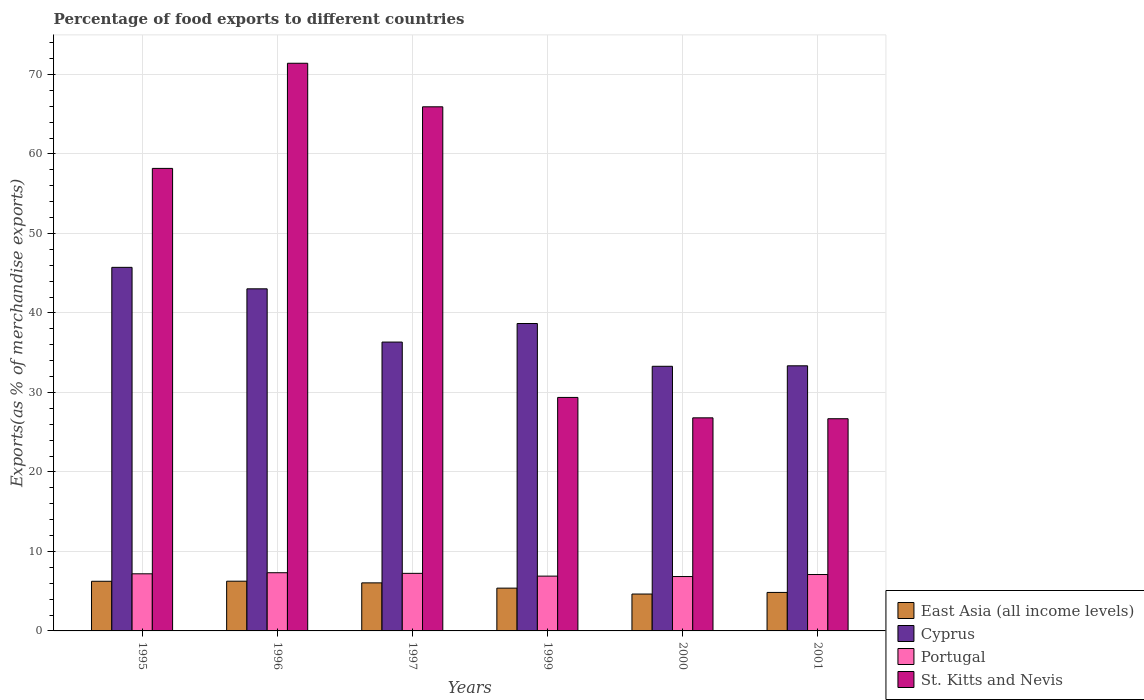How many different coloured bars are there?
Ensure brevity in your answer.  4. Are the number of bars per tick equal to the number of legend labels?
Ensure brevity in your answer.  Yes. How many bars are there on the 3rd tick from the left?
Make the answer very short. 4. What is the label of the 3rd group of bars from the left?
Provide a succinct answer. 1997. In how many cases, is the number of bars for a given year not equal to the number of legend labels?
Provide a short and direct response. 0. What is the percentage of exports to different countries in East Asia (all income levels) in 1997?
Offer a very short reply. 6.05. Across all years, what is the maximum percentage of exports to different countries in Cyprus?
Offer a terse response. 45.74. Across all years, what is the minimum percentage of exports to different countries in Cyprus?
Your answer should be compact. 33.29. In which year was the percentage of exports to different countries in St. Kitts and Nevis maximum?
Keep it short and to the point. 1996. What is the total percentage of exports to different countries in East Asia (all income levels) in the graph?
Provide a short and direct response. 33.41. What is the difference between the percentage of exports to different countries in Cyprus in 1996 and that in 1999?
Offer a terse response. 4.37. What is the difference between the percentage of exports to different countries in Cyprus in 2000 and the percentage of exports to different countries in Portugal in 1996?
Your response must be concise. 25.97. What is the average percentage of exports to different countries in East Asia (all income levels) per year?
Make the answer very short. 5.57. In the year 2001, what is the difference between the percentage of exports to different countries in Portugal and percentage of exports to different countries in St. Kitts and Nevis?
Make the answer very short. -19.6. What is the ratio of the percentage of exports to different countries in Cyprus in 1999 to that in 2001?
Offer a very short reply. 1.16. Is the percentage of exports to different countries in East Asia (all income levels) in 1996 less than that in 1997?
Provide a succinct answer. No. Is the difference between the percentage of exports to different countries in Portugal in 1996 and 2001 greater than the difference between the percentage of exports to different countries in St. Kitts and Nevis in 1996 and 2001?
Your response must be concise. No. What is the difference between the highest and the second highest percentage of exports to different countries in Portugal?
Provide a succinct answer. 0.08. What is the difference between the highest and the lowest percentage of exports to different countries in Portugal?
Your answer should be compact. 0.48. Is it the case that in every year, the sum of the percentage of exports to different countries in Cyprus and percentage of exports to different countries in St. Kitts and Nevis is greater than the sum of percentage of exports to different countries in East Asia (all income levels) and percentage of exports to different countries in Portugal?
Your answer should be very brief. No. What does the 1st bar from the left in 1997 represents?
Keep it short and to the point. East Asia (all income levels). What does the 4th bar from the right in 1999 represents?
Offer a terse response. East Asia (all income levels). Is it the case that in every year, the sum of the percentage of exports to different countries in Portugal and percentage of exports to different countries in Cyprus is greater than the percentage of exports to different countries in East Asia (all income levels)?
Provide a succinct answer. Yes. How many bars are there?
Offer a terse response. 24. How many years are there in the graph?
Your answer should be compact. 6. What is the difference between two consecutive major ticks on the Y-axis?
Offer a very short reply. 10. Does the graph contain any zero values?
Provide a succinct answer. No. Where does the legend appear in the graph?
Provide a short and direct response. Bottom right. What is the title of the graph?
Your response must be concise. Percentage of food exports to different countries. Does "Guyana" appear as one of the legend labels in the graph?
Provide a short and direct response. No. What is the label or title of the X-axis?
Provide a short and direct response. Years. What is the label or title of the Y-axis?
Your answer should be very brief. Exports(as % of merchandise exports). What is the Exports(as % of merchandise exports) of East Asia (all income levels) in 1995?
Your response must be concise. 6.24. What is the Exports(as % of merchandise exports) in Cyprus in 1995?
Provide a short and direct response. 45.74. What is the Exports(as % of merchandise exports) in Portugal in 1995?
Offer a terse response. 7.19. What is the Exports(as % of merchandise exports) in St. Kitts and Nevis in 1995?
Ensure brevity in your answer.  58.18. What is the Exports(as % of merchandise exports) in East Asia (all income levels) in 1996?
Give a very brief answer. 6.25. What is the Exports(as % of merchandise exports) of Cyprus in 1996?
Provide a short and direct response. 43.04. What is the Exports(as % of merchandise exports) in Portugal in 1996?
Offer a terse response. 7.32. What is the Exports(as % of merchandise exports) of St. Kitts and Nevis in 1996?
Provide a short and direct response. 71.41. What is the Exports(as % of merchandise exports) in East Asia (all income levels) in 1997?
Keep it short and to the point. 6.05. What is the Exports(as % of merchandise exports) of Cyprus in 1997?
Your answer should be very brief. 36.34. What is the Exports(as % of merchandise exports) in Portugal in 1997?
Your answer should be compact. 7.24. What is the Exports(as % of merchandise exports) in St. Kitts and Nevis in 1997?
Ensure brevity in your answer.  65.93. What is the Exports(as % of merchandise exports) in East Asia (all income levels) in 1999?
Offer a very short reply. 5.38. What is the Exports(as % of merchandise exports) in Cyprus in 1999?
Offer a terse response. 38.67. What is the Exports(as % of merchandise exports) in Portugal in 1999?
Keep it short and to the point. 6.89. What is the Exports(as % of merchandise exports) in St. Kitts and Nevis in 1999?
Your answer should be very brief. 29.37. What is the Exports(as % of merchandise exports) of East Asia (all income levels) in 2000?
Your answer should be compact. 4.64. What is the Exports(as % of merchandise exports) of Cyprus in 2000?
Offer a terse response. 33.29. What is the Exports(as % of merchandise exports) of Portugal in 2000?
Offer a terse response. 6.84. What is the Exports(as % of merchandise exports) of St. Kitts and Nevis in 2000?
Your response must be concise. 26.8. What is the Exports(as % of merchandise exports) in East Asia (all income levels) in 2001?
Your answer should be very brief. 4.84. What is the Exports(as % of merchandise exports) of Cyprus in 2001?
Your answer should be very brief. 33.35. What is the Exports(as % of merchandise exports) of Portugal in 2001?
Your answer should be very brief. 7.1. What is the Exports(as % of merchandise exports) in St. Kitts and Nevis in 2001?
Keep it short and to the point. 26.69. Across all years, what is the maximum Exports(as % of merchandise exports) of East Asia (all income levels)?
Your answer should be very brief. 6.25. Across all years, what is the maximum Exports(as % of merchandise exports) of Cyprus?
Your response must be concise. 45.74. Across all years, what is the maximum Exports(as % of merchandise exports) in Portugal?
Your answer should be compact. 7.32. Across all years, what is the maximum Exports(as % of merchandise exports) of St. Kitts and Nevis?
Provide a succinct answer. 71.41. Across all years, what is the minimum Exports(as % of merchandise exports) in East Asia (all income levels)?
Ensure brevity in your answer.  4.64. Across all years, what is the minimum Exports(as % of merchandise exports) of Cyprus?
Offer a terse response. 33.29. Across all years, what is the minimum Exports(as % of merchandise exports) of Portugal?
Provide a succinct answer. 6.84. Across all years, what is the minimum Exports(as % of merchandise exports) of St. Kitts and Nevis?
Your response must be concise. 26.69. What is the total Exports(as % of merchandise exports) in East Asia (all income levels) in the graph?
Give a very brief answer. 33.41. What is the total Exports(as % of merchandise exports) in Cyprus in the graph?
Keep it short and to the point. 230.42. What is the total Exports(as % of merchandise exports) of Portugal in the graph?
Offer a terse response. 42.58. What is the total Exports(as % of merchandise exports) in St. Kitts and Nevis in the graph?
Your response must be concise. 278.39. What is the difference between the Exports(as % of merchandise exports) of East Asia (all income levels) in 1995 and that in 1996?
Offer a terse response. -0.01. What is the difference between the Exports(as % of merchandise exports) in Cyprus in 1995 and that in 1996?
Your answer should be very brief. 2.7. What is the difference between the Exports(as % of merchandise exports) in Portugal in 1995 and that in 1996?
Offer a terse response. -0.14. What is the difference between the Exports(as % of merchandise exports) in St. Kitts and Nevis in 1995 and that in 1996?
Give a very brief answer. -13.23. What is the difference between the Exports(as % of merchandise exports) of East Asia (all income levels) in 1995 and that in 1997?
Your answer should be compact. 0.2. What is the difference between the Exports(as % of merchandise exports) in Cyprus in 1995 and that in 1997?
Provide a short and direct response. 9.4. What is the difference between the Exports(as % of merchandise exports) in Portugal in 1995 and that in 1997?
Offer a terse response. -0.06. What is the difference between the Exports(as % of merchandise exports) in St. Kitts and Nevis in 1995 and that in 1997?
Make the answer very short. -7.75. What is the difference between the Exports(as % of merchandise exports) of East Asia (all income levels) in 1995 and that in 1999?
Your answer should be compact. 0.86. What is the difference between the Exports(as % of merchandise exports) of Cyprus in 1995 and that in 1999?
Keep it short and to the point. 7.07. What is the difference between the Exports(as % of merchandise exports) of Portugal in 1995 and that in 1999?
Your answer should be compact. 0.29. What is the difference between the Exports(as % of merchandise exports) of St. Kitts and Nevis in 1995 and that in 1999?
Provide a short and direct response. 28.81. What is the difference between the Exports(as % of merchandise exports) of East Asia (all income levels) in 1995 and that in 2000?
Offer a very short reply. 1.6. What is the difference between the Exports(as % of merchandise exports) of Cyprus in 1995 and that in 2000?
Give a very brief answer. 12.45. What is the difference between the Exports(as % of merchandise exports) of Portugal in 1995 and that in 2000?
Offer a terse response. 0.35. What is the difference between the Exports(as % of merchandise exports) in St. Kitts and Nevis in 1995 and that in 2000?
Provide a short and direct response. 31.38. What is the difference between the Exports(as % of merchandise exports) in East Asia (all income levels) in 1995 and that in 2001?
Offer a very short reply. 1.4. What is the difference between the Exports(as % of merchandise exports) of Cyprus in 1995 and that in 2001?
Offer a very short reply. 12.38. What is the difference between the Exports(as % of merchandise exports) of Portugal in 1995 and that in 2001?
Your response must be concise. 0.09. What is the difference between the Exports(as % of merchandise exports) of St. Kitts and Nevis in 1995 and that in 2001?
Give a very brief answer. 31.49. What is the difference between the Exports(as % of merchandise exports) of East Asia (all income levels) in 1996 and that in 1997?
Offer a terse response. 0.21. What is the difference between the Exports(as % of merchandise exports) of Cyprus in 1996 and that in 1997?
Provide a succinct answer. 6.7. What is the difference between the Exports(as % of merchandise exports) in Portugal in 1996 and that in 1997?
Provide a short and direct response. 0.08. What is the difference between the Exports(as % of merchandise exports) of St. Kitts and Nevis in 1996 and that in 1997?
Your response must be concise. 5.48. What is the difference between the Exports(as % of merchandise exports) of East Asia (all income levels) in 1996 and that in 1999?
Your answer should be compact. 0.87. What is the difference between the Exports(as % of merchandise exports) in Cyprus in 1996 and that in 1999?
Your answer should be compact. 4.37. What is the difference between the Exports(as % of merchandise exports) in Portugal in 1996 and that in 1999?
Keep it short and to the point. 0.43. What is the difference between the Exports(as % of merchandise exports) in St. Kitts and Nevis in 1996 and that in 1999?
Provide a short and direct response. 42.04. What is the difference between the Exports(as % of merchandise exports) in East Asia (all income levels) in 1996 and that in 2000?
Offer a terse response. 1.61. What is the difference between the Exports(as % of merchandise exports) of Cyprus in 1996 and that in 2000?
Your answer should be compact. 9.74. What is the difference between the Exports(as % of merchandise exports) in Portugal in 1996 and that in 2000?
Your response must be concise. 0.48. What is the difference between the Exports(as % of merchandise exports) of St. Kitts and Nevis in 1996 and that in 2000?
Ensure brevity in your answer.  44.6. What is the difference between the Exports(as % of merchandise exports) of East Asia (all income levels) in 1996 and that in 2001?
Ensure brevity in your answer.  1.41. What is the difference between the Exports(as % of merchandise exports) of Cyprus in 1996 and that in 2001?
Provide a succinct answer. 9.68. What is the difference between the Exports(as % of merchandise exports) in Portugal in 1996 and that in 2001?
Ensure brevity in your answer.  0.23. What is the difference between the Exports(as % of merchandise exports) in St. Kitts and Nevis in 1996 and that in 2001?
Give a very brief answer. 44.72. What is the difference between the Exports(as % of merchandise exports) of East Asia (all income levels) in 1997 and that in 1999?
Your answer should be compact. 0.66. What is the difference between the Exports(as % of merchandise exports) of Cyprus in 1997 and that in 1999?
Your response must be concise. -2.33. What is the difference between the Exports(as % of merchandise exports) in Portugal in 1997 and that in 1999?
Make the answer very short. 0.35. What is the difference between the Exports(as % of merchandise exports) in St. Kitts and Nevis in 1997 and that in 1999?
Your answer should be compact. 36.56. What is the difference between the Exports(as % of merchandise exports) of East Asia (all income levels) in 1997 and that in 2000?
Provide a succinct answer. 1.41. What is the difference between the Exports(as % of merchandise exports) of Cyprus in 1997 and that in 2000?
Keep it short and to the point. 3.05. What is the difference between the Exports(as % of merchandise exports) of Portugal in 1997 and that in 2000?
Provide a succinct answer. 0.4. What is the difference between the Exports(as % of merchandise exports) of St. Kitts and Nevis in 1997 and that in 2000?
Ensure brevity in your answer.  39.13. What is the difference between the Exports(as % of merchandise exports) of East Asia (all income levels) in 1997 and that in 2001?
Provide a short and direct response. 1.2. What is the difference between the Exports(as % of merchandise exports) in Cyprus in 1997 and that in 2001?
Offer a very short reply. 2.98. What is the difference between the Exports(as % of merchandise exports) of Portugal in 1997 and that in 2001?
Offer a terse response. 0.15. What is the difference between the Exports(as % of merchandise exports) of St. Kitts and Nevis in 1997 and that in 2001?
Provide a succinct answer. 39.24. What is the difference between the Exports(as % of merchandise exports) in East Asia (all income levels) in 1999 and that in 2000?
Your answer should be compact. 0.74. What is the difference between the Exports(as % of merchandise exports) in Cyprus in 1999 and that in 2000?
Ensure brevity in your answer.  5.38. What is the difference between the Exports(as % of merchandise exports) of Portugal in 1999 and that in 2000?
Your answer should be very brief. 0.05. What is the difference between the Exports(as % of merchandise exports) in St. Kitts and Nevis in 1999 and that in 2000?
Your answer should be compact. 2.57. What is the difference between the Exports(as % of merchandise exports) in East Asia (all income levels) in 1999 and that in 2001?
Your answer should be compact. 0.54. What is the difference between the Exports(as % of merchandise exports) of Cyprus in 1999 and that in 2001?
Provide a short and direct response. 5.32. What is the difference between the Exports(as % of merchandise exports) of Portugal in 1999 and that in 2001?
Your response must be concise. -0.2. What is the difference between the Exports(as % of merchandise exports) of St. Kitts and Nevis in 1999 and that in 2001?
Make the answer very short. 2.68. What is the difference between the Exports(as % of merchandise exports) of East Asia (all income levels) in 2000 and that in 2001?
Offer a terse response. -0.2. What is the difference between the Exports(as % of merchandise exports) of Cyprus in 2000 and that in 2001?
Give a very brief answer. -0.06. What is the difference between the Exports(as % of merchandise exports) of Portugal in 2000 and that in 2001?
Your answer should be compact. -0.25. What is the difference between the Exports(as % of merchandise exports) of St. Kitts and Nevis in 2000 and that in 2001?
Offer a very short reply. 0.11. What is the difference between the Exports(as % of merchandise exports) of East Asia (all income levels) in 1995 and the Exports(as % of merchandise exports) of Cyprus in 1996?
Provide a succinct answer. -36.79. What is the difference between the Exports(as % of merchandise exports) of East Asia (all income levels) in 1995 and the Exports(as % of merchandise exports) of Portugal in 1996?
Your response must be concise. -1.08. What is the difference between the Exports(as % of merchandise exports) of East Asia (all income levels) in 1995 and the Exports(as % of merchandise exports) of St. Kitts and Nevis in 1996?
Your answer should be very brief. -65.16. What is the difference between the Exports(as % of merchandise exports) in Cyprus in 1995 and the Exports(as % of merchandise exports) in Portugal in 1996?
Offer a terse response. 38.41. What is the difference between the Exports(as % of merchandise exports) of Cyprus in 1995 and the Exports(as % of merchandise exports) of St. Kitts and Nevis in 1996?
Make the answer very short. -25.67. What is the difference between the Exports(as % of merchandise exports) in Portugal in 1995 and the Exports(as % of merchandise exports) in St. Kitts and Nevis in 1996?
Provide a succinct answer. -64.22. What is the difference between the Exports(as % of merchandise exports) of East Asia (all income levels) in 1995 and the Exports(as % of merchandise exports) of Cyprus in 1997?
Offer a very short reply. -30.09. What is the difference between the Exports(as % of merchandise exports) of East Asia (all income levels) in 1995 and the Exports(as % of merchandise exports) of Portugal in 1997?
Provide a succinct answer. -1. What is the difference between the Exports(as % of merchandise exports) of East Asia (all income levels) in 1995 and the Exports(as % of merchandise exports) of St. Kitts and Nevis in 1997?
Your response must be concise. -59.69. What is the difference between the Exports(as % of merchandise exports) in Cyprus in 1995 and the Exports(as % of merchandise exports) in Portugal in 1997?
Provide a short and direct response. 38.49. What is the difference between the Exports(as % of merchandise exports) in Cyprus in 1995 and the Exports(as % of merchandise exports) in St. Kitts and Nevis in 1997?
Ensure brevity in your answer.  -20.2. What is the difference between the Exports(as % of merchandise exports) in Portugal in 1995 and the Exports(as % of merchandise exports) in St. Kitts and Nevis in 1997?
Your response must be concise. -58.75. What is the difference between the Exports(as % of merchandise exports) in East Asia (all income levels) in 1995 and the Exports(as % of merchandise exports) in Cyprus in 1999?
Provide a succinct answer. -32.42. What is the difference between the Exports(as % of merchandise exports) of East Asia (all income levels) in 1995 and the Exports(as % of merchandise exports) of Portugal in 1999?
Your answer should be compact. -0.65. What is the difference between the Exports(as % of merchandise exports) in East Asia (all income levels) in 1995 and the Exports(as % of merchandise exports) in St. Kitts and Nevis in 1999?
Your answer should be very brief. -23.13. What is the difference between the Exports(as % of merchandise exports) in Cyprus in 1995 and the Exports(as % of merchandise exports) in Portugal in 1999?
Give a very brief answer. 38.84. What is the difference between the Exports(as % of merchandise exports) in Cyprus in 1995 and the Exports(as % of merchandise exports) in St. Kitts and Nevis in 1999?
Make the answer very short. 16.36. What is the difference between the Exports(as % of merchandise exports) of Portugal in 1995 and the Exports(as % of merchandise exports) of St. Kitts and Nevis in 1999?
Ensure brevity in your answer.  -22.19. What is the difference between the Exports(as % of merchandise exports) in East Asia (all income levels) in 1995 and the Exports(as % of merchandise exports) in Cyprus in 2000?
Provide a short and direct response. -27.05. What is the difference between the Exports(as % of merchandise exports) of East Asia (all income levels) in 1995 and the Exports(as % of merchandise exports) of Portugal in 2000?
Offer a very short reply. -0.6. What is the difference between the Exports(as % of merchandise exports) of East Asia (all income levels) in 1995 and the Exports(as % of merchandise exports) of St. Kitts and Nevis in 2000?
Provide a succinct answer. -20.56. What is the difference between the Exports(as % of merchandise exports) of Cyprus in 1995 and the Exports(as % of merchandise exports) of Portugal in 2000?
Your answer should be compact. 38.9. What is the difference between the Exports(as % of merchandise exports) of Cyprus in 1995 and the Exports(as % of merchandise exports) of St. Kitts and Nevis in 2000?
Ensure brevity in your answer.  18.93. What is the difference between the Exports(as % of merchandise exports) of Portugal in 1995 and the Exports(as % of merchandise exports) of St. Kitts and Nevis in 2000?
Ensure brevity in your answer.  -19.62. What is the difference between the Exports(as % of merchandise exports) in East Asia (all income levels) in 1995 and the Exports(as % of merchandise exports) in Cyprus in 2001?
Give a very brief answer. -27.11. What is the difference between the Exports(as % of merchandise exports) of East Asia (all income levels) in 1995 and the Exports(as % of merchandise exports) of Portugal in 2001?
Offer a terse response. -0.85. What is the difference between the Exports(as % of merchandise exports) of East Asia (all income levels) in 1995 and the Exports(as % of merchandise exports) of St. Kitts and Nevis in 2001?
Offer a terse response. -20.45. What is the difference between the Exports(as % of merchandise exports) in Cyprus in 1995 and the Exports(as % of merchandise exports) in Portugal in 2001?
Provide a succinct answer. 38.64. What is the difference between the Exports(as % of merchandise exports) of Cyprus in 1995 and the Exports(as % of merchandise exports) of St. Kitts and Nevis in 2001?
Your response must be concise. 19.04. What is the difference between the Exports(as % of merchandise exports) of Portugal in 1995 and the Exports(as % of merchandise exports) of St. Kitts and Nevis in 2001?
Offer a very short reply. -19.51. What is the difference between the Exports(as % of merchandise exports) in East Asia (all income levels) in 1996 and the Exports(as % of merchandise exports) in Cyprus in 1997?
Your response must be concise. -30.08. What is the difference between the Exports(as % of merchandise exports) of East Asia (all income levels) in 1996 and the Exports(as % of merchandise exports) of Portugal in 1997?
Ensure brevity in your answer.  -0.99. What is the difference between the Exports(as % of merchandise exports) in East Asia (all income levels) in 1996 and the Exports(as % of merchandise exports) in St. Kitts and Nevis in 1997?
Ensure brevity in your answer.  -59.68. What is the difference between the Exports(as % of merchandise exports) in Cyprus in 1996 and the Exports(as % of merchandise exports) in Portugal in 1997?
Keep it short and to the point. 35.79. What is the difference between the Exports(as % of merchandise exports) in Cyprus in 1996 and the Exports(as % of merchandise exports) in St. Kitts and Nevis in 1997?
Offer a terse response. -22.9. What is the difference between the Exports(as % of merchandise exports) of Portugal in 1996 and the Exports(as % of merchandise exports) of St. Kitts and Nevis in 1997?
Your answer should be compact. -58.61. What is the difference between the Exports(as % of merchandise exports) in East Asia (all income levels) in 1996 and the Exports(as % of merchandise exports) in Cyprus in 1999?
Offer a terse response. -32.42. What is the difference between the Exports(as % of merchandise exports) of East Asia (all income levels) in 1996 and the Exports(as % of merchandise exports) of Portugal in 1999?
Offer a terse response. -0.64. What is the difference between the Exports(as % of merchandise exports) in East Asia (all income levels) in 1996 and the Exports(as % of merchandise exports) in St. Kitts and Nevis in 1999?
Make the answer very short. -23.12. What is the difference between the Exports(as % of merchandise exports) of Cyprus in 1996 and the Exports(as % of merchandise exports) of Portugal in 1999?
Your answer should be very brief. 36.14. What is the difference between the Exports(as % of merchandise exports) in Cyprus in 1996 and the Exports(as % of merchandise exports) in St. Kitts and Nevis in 1999?
Your answer should be compact. 13.66. What is the difference between the Exports(as % of merchandise exports) of Portugal in 1996 and the Exports(as % of merchandise exports) of St. Kitts and Nevis in 1999?
Your answer should be compact. -22.05. What is the difference between the Exports(as % of merchandise exports) of East Asia (all income levels) in 1996 and the Exports(as % of merchandise exports) of Cyprus in 2000?
Your response must be concise. -27.04. What is the difference between the Exports(as % of merchandise exports) of East Asia (all income levels) in 1996 and the Exports(as % of merchandise exports) of Portugal in 2000?
Offer a very short reply. -0.59. What is the difference between the Exports(as % of merchandise exports) of East Asia (all income levels) in 1996 and the Exports(as % of merchandise exports) of St. Kitts and Nevis in 2000?
Offer a terse response. -20.55. What is the difference between the Exports(as % of merchandise exports) in Cyprus in 1996 and the Exports(as % of merchandise exports) in Portugal in 2000?
Give a very brief answer. 36.19. What is the difference between the Exports(as % of merchandise exports) of Cyprus in 1996 and the Exports(as % of merchandise exports) of St. Kitts and Nevis in 2000?
Ensure brevity in your answer.  16.23. What is the difference between the Exports(as % of merchandise exports) in Portugal in 1996 and the Exports(as % of merchandise exports) in St. Kitts and Nevis in 2000?
Your answer should be very brief. -19.48. What is the difference between the Exports(as % of merchandise exports) of East Asia (all income levels) in 1996 and the Exports(as % of merchandise exports) of Cyprus in 2001?
Give a very brief answer. -27.1. What is the difference between the Exports(as % of merchandise exports) of East Asia (all income levels) in 1996 and the Exports(as % of merchandise exports) of Portugal in 2001?
Your answer should be compact. -0.84. What is the difference between the Exports(as % of merchandise exports) in East Asia (all income levels) in 1996 and the Exports(as % of merchandise exports) in St. Kitts and Nevis in 2001?
Your answer should be compact. -20.44. What is the difference between the Exports(as % of merchandise exports) in Cyprus in 1996 and the Exports(as % of merchandise exports) in Portugal in 2001?
Offer a terse response. 35.94. What is the difference between the Exports(as % of merchandise exports) of Cyprus in 1996 and the Exports(as % of merchandise exports) of St. Kitts and Nevis in 2001?
Your answer should be compact. 16.34. What is the difference between the Exports(as % of merchandise exports) in Portugal in 1996 and the Exports(as % of merchandise exports) in St. Kitts and Nevis in 2001?
Your response must be concise. -19.37. What is the difference between the Exports(as % of merchandise exports) in East Asia (all income levels) in 1997 and the Exports(as % of merchandise exports) in Cyprus in 1999?
Offer a terse response. -32.62. What is the difference between the Exports(as % of merchandise exports) in East Asia (all income levels) in 1997 and the Exports(as % of merchandise exports) in Portugal in 1999?
Keep it short and to the point. -0.85. What is the difference between the Exports(as % of merchandise exports) in East Asia (all income levels) in 1997 and the Exports(as % of merchandise exports) in St. Kitts and Nevis in 1999?
Keep it short and to the point. -23.33. What is the difference between the Exports(as % of merchandise exports) of Cyprus in 1997 and the Exports(as % of merchandise exports) of Portugal in 1999?
Offer a terse response. 29.44. What is the difference between the Exports(as % of merchandise exports) in Cyprus in 1997 and the Exports(as % of merchandise exports) in St. Kitts and Nevis in 1999?
Your answer should be very brief. 6.96. What is the difference between the Exports(as % of merchandise exports) in Portugal in 1997 and the Exports(as % of merchandise exports) in St. Kitts and Nevis in 1999?
Provide a short and direct response. -22.13. What is the difference between the Exports(as % of merchandise exports) of East Asia (all income levels) in 1997 and the Exports(as % of merchandise exports) of Cyprus in 2000?
Offer a terse response. -27.24. What is the difference between the Exports(as % of merchandise exports) of East Asia (all income levels) in 1997 and the Exports(as % of merchandise exports) of Portugal in 2000?
Your response must be concise. -0.79. What is the difference between the Exports(as % of merchandise exports) of East Asia (all income levels) in 1997 and the Exports(as % of merchandise exports) of St. Kitts and Nevis in 2000?
Make the answer very short. -20.76. What is the difference between the Exports(as % of merchandise exports) of Cyprus in 1997 and the Exports(as % of merchandise exports) of Portugal in 2000?
Your answer should be very brief. 29.5. What is the difference between the Exports(as % of merchandise exports) in Cyprus in 1997 and the Exports(as % of merchandise exports) in St. Kitts and Nevis in 2000?
Offer a very short reply. 9.53. What is the difference between the Exports(as % of merchandise exports) in Portugal in 1997 and the Exports(as % of merchandise exports) in St. Kitts and Nevis in 2000?
Your answer should be very brief. -19.56. What is the difference between the Exports(as % of merchandise exports) of East Asia (all income levels) in 1997 and the Exports(as % of merchandise exports) of Cyprus in 2001?
Ensure brevity in your answer.  -27.31. What is the difference between the Exports(as % of merchandise exports) of East Asia (all income levels) in 1997 and the Exports(as % of merchandise exports) of Portugal in 2001?
Give a very brief answer. -1.05. What is the difference between the Exports(as % of merchandise exports) in East Asia (all income levels) in 1997 and the Exports(as % of merchandise exports) in St. Kitts and Nevis in 2001?
Offer a very short reply. -20.65. What is the difference between the Exports(as % of merchandise exports) of Cyprus in 1997 and the Exports(as % of merchandise exports) of Portugal in 2001?
Ensure brevity in your answer.  29.24. What is the difference between the Exports(as % of merchandise exports) of Cyprus in 1997 and the Exports(as % of merchandise exports) of St. Kitts and Nevis in 2001?
Give a very brief answer. 9.64. What is the difference between the Exports(as % of merchandise exports) of Portugal in 1997 and the Exports(as % of merchandise exports) of St. Kitts and Nevis in 2001?
Your response must be concise. -19.45. What is the difference between the Exports(as % of merchandise exports) of East Asia (all income levels) in 1999 and the Exports(as % of merchandise exports) of Cyprus in 2000?
Your answer should be very brief. -27.91. What is the difference between the Exports(as % of merchandise exports) in East Asia (all income levels) in 1999 and the Exports(as % of merchandise exports) in Portugal in 2000?
Ensure brevity in your answer.  -1.46. What is the difference between the Exports(as % of merchandise exports) in East Asia (all income levels) in 1999 and the Exports(as % of merchandise exports) in St. Kitts and Nevis in 2000?
Provide a succinct answer. -21.42. What is the difference between the Exports(as % of merchandise exports) of Cyprus in 1999 and the Exports(as % of merchandise exports) of Portugal in 2000?
Provide a succinct answer. 31.83. What is the difference between the Exports(as % of merchandise exports) of Cyprus in 1999 and the Exports(as % of merchandise exports) of St. Kitts and Nevis in 2000?
Make the answer very short. 11.87. What is the difference between the Exports(as % of merchandise exports) in Portugal in 1999 and the Exports(as % of merchandise exports) in St. Kitts and Nevis in 2000?
Offer a very short reply. -19.91. What is the difference between the Exports(as % of merchandise exports) of East Asia (all income levels) in 1999 and the Exports(as % of merchandise exports) of Cyprus in 2001?
Make the answer very short. -27.97. What is the difference between the Exports(as % of merchandise exports) of East Asia (all income levels) in 1999 and the Exports(as % of merchandise exports) of Portugal in 2001?
Offer a very short reply. -1.71. What is the difference between the Exports(as % of merchandise exports) in East Asia (all income levels) in 1999 and the Exports(as % of merchandise exports) in St. Kitts and Nevis in 2001?
Keep it short and to the point. -21.31. What is the difference between the Exports(as % of merchandise exports) in Cyprus in 1999 and the Exports(as % of merchandise exports) in Portugal in 2001?
Offer a very short reply. 31.57. What is the difference between the Exports(as % of merchandise exports) of Cyprus in 1999 and the Exports(as % of merchandise exports) of St. Kitts and Nevis in 2001?
Your response must be concise. 11.98. What is the difference between the Exports(as % of merchandise exports) of Portugal in 1999 and the Exports(as % of merchandise exports) of St. Kitts and Nevis in 2001?
Your answer should be very brief. -19.8. What is the difference between the Exports(as % of merchandise exports) in East Asia (all income levels) in 2000 and the Exports(as % of merchandise exports) in Cyprus in 2001?
Offer a terse response. -28.71. What is the difference between the Exports(as % of merchandise exports) in East Asia (all income levels) in 2000 and the Exports(as % of merchandise exports) in Portugal in 2001?
Your response must be concise. -2.45. What is the difference between the Exports(as % of merchandise exports) of East Asia (all income levels) in 2000 and the Exports(as % of merchandise exports) of St. Kitts and Nevis in 2001?
Give a very brief answer. -22.05. What is the difference between the Exports(as % of merchandise exports) of Cyprus in 2000 and the Exports(as % of merchandise exports) of Portugal in 2001?
Ensure brevity in your answer.  26.19. What is the difference between the Exports(as % of merchandise exports) of Cyprus in 2000 and the Exports(as % of merchandise exports) of St. Kitts and Nevis in 2001?
Your response must be concise. 6.6. What is the difference between the Exports(as % of merchandise exports) in Portugal in 2000 and the Exports(as % of merchandise exports) in St. Kitts and Nevis in 2001?
Keep it short and to the point. -19.85. What is the average Exports(as % of merchandise exports) of East Asia (all income levels) per year?
Ensure brevity in your answer.  5.57. What is the average Exports(as % of merchandise exports) of Cyprus per year?
Offer a very short reply. 38.4. What is the average Exports(as % of merchandise exports) in Portugal per year?
Offer a very short reply. 7.1. What is the average Exports(as % of merchandise exports) of St. Kitts and Nevis per year?
Offer a very short reply. 46.4. In the year 1995, what is the difference between the Exports(as % of merchandise exports) of East Asia (all income levels) and Exports(as % of merchandise exports) of Cyprus?
Offer a very short reply. -39.49. In the year 1995, what is the difference between the Exports(as % of merchandise exports) in East Asia (all income levels) and Exports(as % of merchandise exports) in Portugal?
Keep it short and to the point. -0.94. In the year 1995, what is the difference between the Exports(as % of merchandise exports) in East Asia (all income levels) and Exports(as % of merchandise exports) in St. Kitts and Nevis?
Offer a very short reply. -51.94. In the year 1995, what is the difference between the Exports(as % of merchandise exports) in Cyprus and Exports(as % of merchandise exports) in Portugal?
Your answer should be very brief. 38.55. In the year 1995, what is the difference between the Exports(as % of merchandise exports) in Cyprus and Exports(as % of merchandise exports) in St. Kitts and Nevis?
Your answer should be very brief. -12.45. In the year 1995, what is the difference between the Exports(as % of merchandise exports) in Portugal and Exports(as % of merchandise exports) in St. Kitts and Nevis?
Give a very brief answer. -51. In the year 1996, what is the difference between the Exports(as % of merchandise exports) of East Asia (all income levels) and Exports(as % of merchandise exports) of Cyprus?
Your answer should be compact. -36.78. In the year 1996, what is the difference between the Exports(as % of merchandise exports) of East Asia (all income levels) and Exports(as % of merchandise exports) of Portugal?
Provide a succinct answer. -1.07. In the year 1996, what is the difference between the Exports(as % of merchandise exports) in East Asia (all income levels) and Exports(as % of merchandise exports) in St. Kitts and Nevis?
Provide a succinct answer. -65.15. In the year 1996, what is the difference between the Exports(as % of merchandise exports) in Cyprus and Exports(as % of merchandise exports) in Portugal?
Offer a very short reply. 35.71. In the year 1996, what is the difference between the Exports(as % of merchandise exports) in Cyprus and Exports(as % of merchandise exports) in St. Kitts and Nevis?
Your answer should be compact. -28.37. In the year 1996, what is the difference between the Exports(as % of merchandise exports) of Portugal and Exports(as % of merchandise exports) of St. Kitts and Nevis?
Offer a terse response. -64.09. In the year 1997, what is the difference between the Exports(as % of merchandise exports) in East Asia (all income levels) and Exports(as % of merchandise exports) in Cyprus?
Offer a terse response. -30.29. In the year 1997, what is the difference between the Exports(as % of merchandise exports) in East Asia (all income levels) and Exports(as % of merchandise exports) in Portugal?
Your response must be concise. -1.2. In the year 1997, what is the difference between the Exports(as % of merchandise exports) of East Asia (all income levels) and Exports(as % of merchandise exports) of St. Kitts and Nevis?
Make the answer very short. -59.89. In the year 1997, what is the difference between the Exports(as % of merchandise exports) of Cyprus and Exports(as % of merchandise exports) of Portugal?
Your answer should be very brief. 29.09. In the year 1997, what is the difference between the Exports(as % of merchandise exports) of Cyprus and Exports(as % of merchandise exports) of St. Kitts and Nevis?
Your answer should be compact. -29.6. In the year 1997, what is the difference between the Exports(as % of merchandise exports) in Portugal and Exports(as % of merchandise exports) in St. Kitts and Nevis?
Offer a very short reply. -58.69. In the year 1999, what is the difference between the Exports(as % of merchandise exports) of East Asia (all income levels) and Exports(as % of merchandise exports) of Cyprus?
Keep it short and to the point. -33.29. In the year 1999, what is the difference between the Exports(as % of merchandise exports) of East Asia (all income levels) and Exports(as % of merchandise exports) of Portugal?
Provide a succinct answer. -1.51. In the year 1999, what is the difference between the Exports(as % of merchandise exports) in East Asia (all income levels) and Exports(as % of merchandise exports) in St. Kitts and Nevis?
Make the answer very short. -23.99. In the year 1999, what is the difference between the Exports(as % of merchandise exports) of Cyprus and Exports(as % of merchandise exports) of Portugal?
Ensure brevity in your answer.  31.78. In the year 1999, what is the difference between the Exports(as % of merchandise exports) in Cyprus and Exports(as % of merchandise exports) in St. Kitts and Nevis?
Your response must be concise. 9.3. In the year 1999, what is the difference between the Exports(as % of merchandise exports) of Portugal and Exports(as % of merchandise exports) of St. Kitts and Nevis?
Make the answer very short. -22.48. In the year 2000, what is the difference between the Exports(as % of merchandise exports) of East Asia (all income levels) and Exports(as % of merchandise exports) of Cyprus?
Offer a terse response. -28.65. In the year 2000, what is the difference between the Exports(as % of merchandise exports) in East Asia (all income levels) and Exports(as % of merchandise exports) in Portugal?
Offer a very short reply. -2.2. In the year 2000, what is the difference between the Exports(as % of merchandise exports) in East Asia (all income levels) and Exports(as % of merchandise exports) in St. Kitts and Nevis?
Provide a short and direct response. -22.16. In the year 2000, what is the difference between the Exports(as % of merchandise exports) in Cyprus and Exports(as % of merchandise exports) in Portugal?
Keep it short and to the point. 26.45. In the year 2000, what is the difference between the Exports(as % of merchandise exports) in Cyprus and Exports(as % of merchandise exports) in St. Kitts and Nevis?
Your answer should be compact. 6.49. In the year 2000, what is the difference between the Exports(as % of merchandise exports) in Portugal and Exports(as % of merchandise exports) in St. Kitts and Nevis?
Your answer should be very brief. -19.96. In the year 2001, what is the difference between the Exports(as % of merchandise exports) in East Asia (all income levels) and Exports(as % of merchandise exports) in Cyprus?
Provide a short and direct response. -28.51. In the year 2001, what is the difference between the Exports(as % of merchandise exports) in East Asia (all income levels) and Exports(as % of merchandise exports) in Portugal?
Provide a short and direct response. -2.25. In the year 2001, what is the difference between the Exports(as % of merchandise exports) in East Asia (all income levels) and Exports(as % of merchandise exports) in St. Kitts and Nevis?
Provide a short and direct response. -21.85. In the year 2001, what is the difference between the Exports(as % of merchandise exports) of Cyprus and Exports(as % of merchandise exports) of Portugal?
Provide a succinct answer. 26.26. In the year 2001, what is the difference between the Exports(as % of merchandise exports) of Cyprus and Exports(as % of merchandise exports) of St. Kitts and Nevis?
Offer a very short reply. 6.66. In the year 2001, what is the difference between the Exports(as % of merchandise exports) of Portugal and Exports(as % of merchandise exports) of St. Kitts and Nevis?
Your answer should be very brief. -19.6. What is the ratio of the Exports(as % of merchandise exports) of East Asia (all income levels) in 1995 to that in 1996?
Give a very brief answer. 1. What is the ratio of the Exports(as % of merchandise exports) of Cyprus in 1995 to that in 1996?
Your answer should be compact. 1.06. What is the ratio of the Exports(as % of merchandise exports) in Portugal in 1995 to that in 1996?
Provide a succinct answer. 0.98. What is the ratio of the Exports(as % of merchandise exports) of St. Kitts and Nevis in 1995 to that in 1996?
Provide a succinct answer. 0.81. What is the ratio of the Exports(as % of merchandise exports) in East Asia (all income levels) in 1995 to that in 1997?
Ensure brevity in your answer.  1.03. What is the ratio of the Exports(as % of merchandise exports) in Cyprus in 1995 to that in 1997?
Offer a terse response. 1.26. What is the ratio of the Exports(as % of merchandise exports) in Portugal in 1995 to that in 1997?
Provide a short and direct response. 0.99. What is the ratio of the Exports(as % of merchandise exports) of St. Kitts and Nevis in 1995 to that in 1997?
Your response must be concise. 0.88. What is the ratio of the Exports(as % of merchandise exports) in East Asia (all income levels) in 1995 to that in 1999?
Offer a terse response. 1.16. What is the ratio of the Exports(as % of merchandise exports) in Cyprus in 1995 to that in 1999?
Ensure brevity in your answer.  1.18. What is the ratio of the Exports(as % of merchandise exports) of Portugal in 1995 to that in 1999?
Offer a terse response. 1.04. What is the ratio of the Exports(as % of merchandise exports) in St. Kitts and Nevis in 1995 to that in 1999?
Your answer should be very brief. 1.98. What is the ratio of the Exports(as % of merchandise exports) in East Asia (all income levels) in 1995 to that in 2000?
Your answer should be very brief. 1.35. What is the ratio of the Exports(as % of merchandise exports) in Cyprus in 1995 to that in 2000?
Your answer should be very brief. 1.37. What is the ratio of the Exports(as % of merchandise exports) in Portugal in 1995 to that in 2000?
Make the answer very short. 1.05. What is the ratio of the Exports(as % of merchandise exports) in St. Kitts and Nevis in 1995 to that in 2000?
Your answer should be compact. 2.17. What is the ratio of the Exports(as % of merchandise exports) in East Asia (all income levels) in 1995 to that in 2001?
Your answer should be very brief. 1.29. What is the ratio of the Exports(as % of merchandise exports) in Cyprus in 1995 to that in 2001?
Provide a short and direct response. 1.37. What is the ratio of the Exports(as % of merchandise exports) of Portugal in 1995 to that in 2001?
Make the answer very short. 1.01. What is the ratio of the Exports(as % of merchandise exports) in St. Kitts and Nevis in 1995 to that in 2001?
Give a very brief answer. 2.18. What is the ratio of the Exports(as % of merchandise exports) in East Asia (all income levels) in 1996 to that in 1997?
Provide a succinct answer. 1.03. What is the ratio of the Exports(as % of merchandise exports) of Cyprus in 1996 to that in 1997?
Your response must be concise. 1.18. What is the ratio of the Exports(as % of merchandise exports) in St. Kitts and Nevis in 1996 to that in 1997?
Your answer should be very brief. 1.08. What is the ratio of the Exports(as % of merchandise exports) of East Asia (all income levels) in 1996 to that in 1999?
Your answer should be very brief. 1.16. What is the ratio of the Exports(as % of merchandise exports) in Cyprus in 1996 to that in 1999?
Your response must be concise. 1.11. What is the ratio of the Exports(as % of merchandise exports) of Portugal in 1996 to that in 1999?
Provide a short and direct response. 1.06. What is the ratio of the Exports(as % of merchandise exports) of St. Kitts and Nevis in 1996 to that in 1999?
Your response must be concise. 2.43. What is the ratio of the Exports(as % of merchandise exports) of East Asia (all income levels) in 1996 to that in 2000?
Your response must be concise. 1.35. What is the ratio of the Exports(as % of merchandise exports) in Cyprus in 1996 to that in 2000?
Ensure brevity in your answer.  1.29. What is the ratio of the Exports(as % of merchandise exports) of Portugal in 1996 to that in 2000?
Your response must be concise. 1.07. What is the ratio of the Exports(as % of merchandise exports) of St. Kitts and Nevis in 1996 to that in 2000?
Ensure brevity in your answer.  2.66. What is the ratio of the Exports(as % of merchandise exports) in East Asia (all income levels) in 1996 to that in 2001?
Give a very brief answer. 1.29. What is the ratio of the Exports(as % of merchandise exports) in Cyprus in 1996 to that in 2001?
Provide a short and direct response. 1.29. What is the ratio of the Exports(as % of merchandise exports) of Portugal in 1996 to that in 2001?
Ensure brevity in your answer.  1.03. What is the ratio of the Exports(as % of merchandise exports) of St. Kitts and Nevis in 1996 to that in 2001?
Ensure brevity in your answer.  2.68. What is the ratio of the Exports(as % of merchandise exports) in East Asia (all income levels) in 1997 to that in 1999?
Keep it short and to the point. 1.12. What is the ratio of the Exports(as % of merchandise exports) in Cyprus in 1997 to that in 1999?
Your answer should be compact. 0.94. What is the ratio of the Exports(as % of merchandise exports) of Portugal in 1997 to that in 1999?
Make the answer very short. 1.05. What is the ratio of the Exports(as % of merchandise exports) in St. Kitts and Nevis in 1997 to that in 1999?
Provide a short and direct response. 2.24. What is the ratio of the Exports(as % of merchandise exports) in East Asia (all income levels) in 1997 to that in 2000?
Offer a terse response. 1.3. What is the ratio of the Exports(as % of merchandise exports) in Cyprus in 1997 to that in 2000?
Make the answer very short. 1.09. What is the ratio of the Exports(as % of merchandise exports) in Portugal in 1997 to that in 2000?
Your answer should be compact. 1.06. What is the ratio of the Exports(as % of merchandise exports) in St. Kitts and Nevis in 1997 to that in 2000?
Ensure brevity in your answer.  2.46. What is the ratio of the Exports(as % of merchandise exports) of East Asia (all income levels) in 1997 to that in 2001?
Provide a short and direct response. 1.25. What is the ratio of the Exports(as % of merchandise exports) of Cyprus in 1997 to that in 2001?
Keep it short and to the point. 1.09. What is the ratio of the Exports(as % of merchandise exports) of Portugal in 1997 to that in 2001?
Your answer should be very brief. 1.02. What is the ratio of the Exports(as % of merchandise exports) of St. Kitts and Nevis in 1997 to that in 2001?
Your answer should be compact. 2.47. What is the ratio of the Exports(as % of merchandise exports) in East Asia (all income levels) in 1999 to that in 2000?
Provide a succinct answer. 1.16. What is the ratio of the Exports(as % of merchandise exports) of Cyprus in 1999 to that in 2000?
Your response must be concise. 1.16. What is the ratio of the Exports(as % of merchandise exports) of Portugal in 1999 to that in 2000?
Your answer should be very brief. 1.01. What is the ratio of the Exports(as % of merchandise exports) of St. Kitts and Nevis in 1999 to that in 2000?
Offer a terse response. 1.1. What is the ratio of the Exports(as % of merchandise exports) of East Asia (all income levels) in 1999 to that in 2001?
Provide a succinct answer. 1.11. What is the ratio of the Exports(as % of merchandise exports) of Cyprus in 1999 to that in 2001?
Your answer should be very brief. 1.16. What is the ratio of the Exports(as % of merchandise exports) of Portugal in 1999 to that in 2001?
Provide a succinct answer. 0.97. What is the ratio of the Exports(as % of merchandise exports) in St. Kitts and Nevis in 1999 to that in 2001?
Offer a very short reply. 1.1. What is the ratio of the Exports(as % of merchandise exports) in East Asia (all income levels) in 2000 to that in 2001?
Provide a succinct answer. 0.96. What is the ratio of the Exports(as % of merchandise exports) in Portugal in 2000 to that in 2001?
Ensure brevity in your answer.  0.96. What is the ratio of the Exports(as % of merchandise exports) of St. Kitts and Nevis in 2000 to that in 2001?
Make the answer very short. 1. What is the difference between the highest and the second highest Exports(as % of merchandise exports) in East Asia (all income levels)?
Offer a very short reply. 0.01. What is the difference between the highest and the second highest Exports(as % of merchandise exports) in Cyprus?
Provide a short and direct response. 2.7. What is the difference between the highest and the second highest Exports(as % of merchandise exports) of Portugal?
Provide a short and direct response. 0.08. What is the difference between the highest and the second highest Exports(as % of merchandise exports) in St. Kitts and Nevis?
Keep it short and to the point. 5.48. What is the difference between the highest and the lowest Exports(as % of merchandise exports) in East Asia (all income levels)?
Your response must be concise. 1.61. What is the difference between the highest and the lowest Exports(as % of merchandise exports) in Cyprus?
Your response must be concise. 12.45. What is the difference between the highest and the lowest Exports(as % of merchandise exports) in Portugal?
Provide a short and direct response. 0.48. What is the difference between the highest and the lowest Exports(as % of merchandise exports) of St. Kitts and Nevis?
Provide a succinct answer. 44.72. 